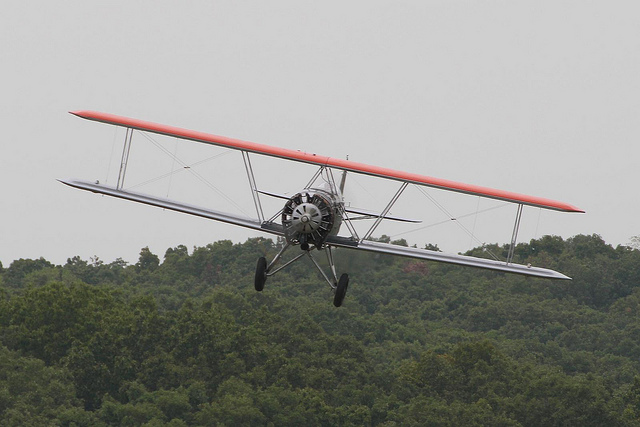What type of airplane is shown in this image? The aircraft depicted in the image is, indeed, a biplane, characterized by its two sets of wings stacked one above the other. This particular design is classic of early aviation and was widely used during the World War I era for its improved maneuverability and lift compared to monoplane designs. 